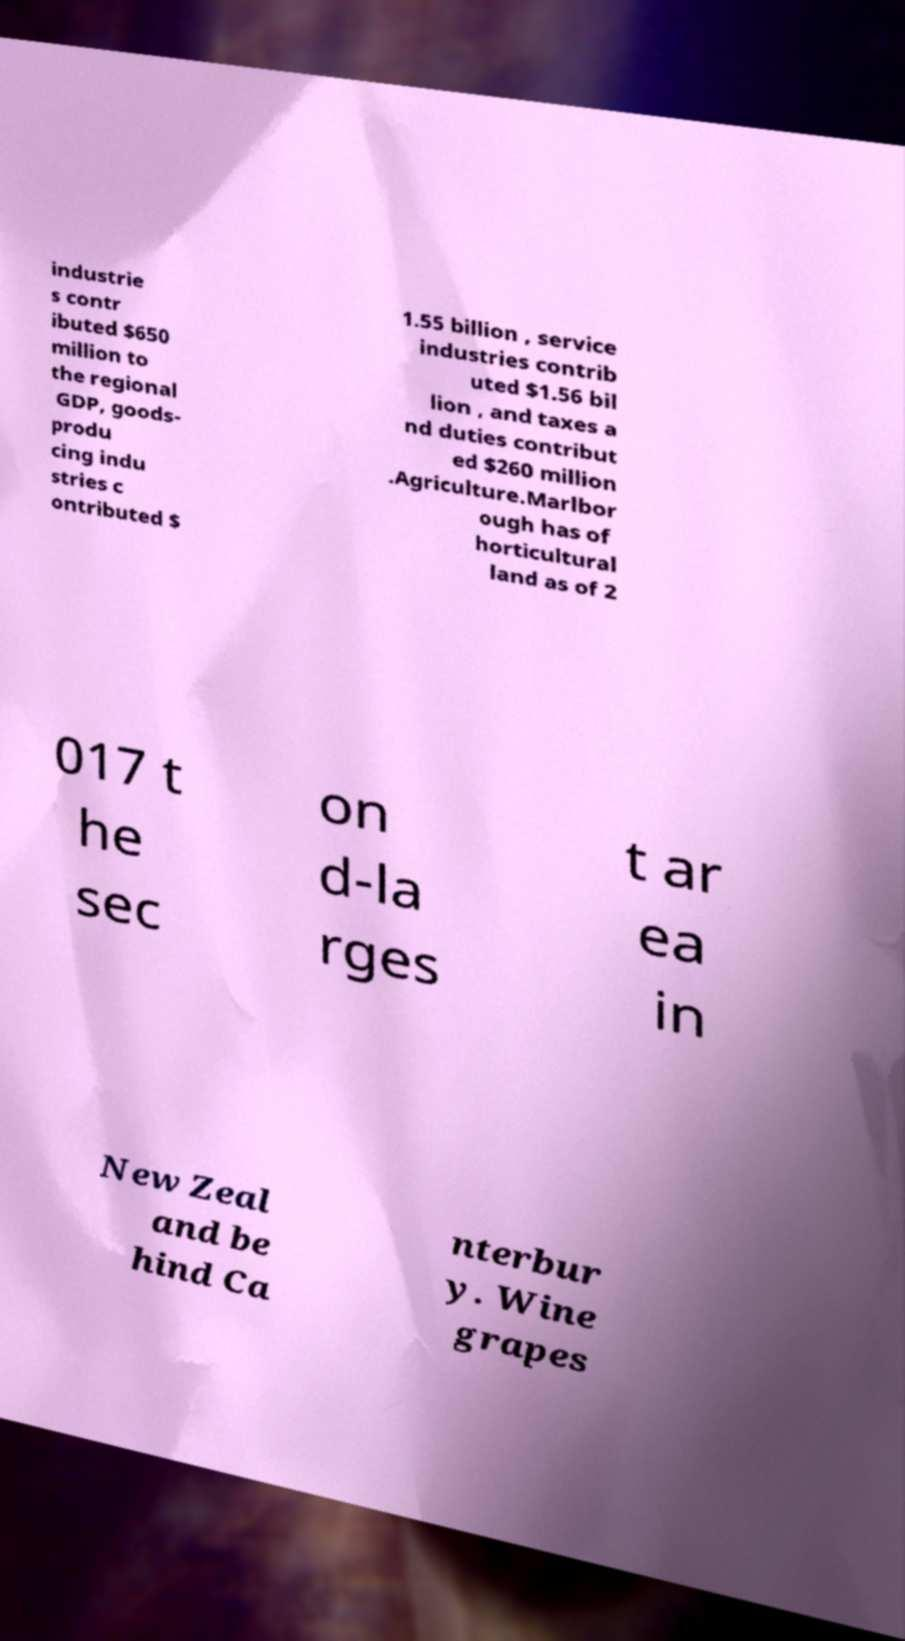Can you read and provide the text displayed in the image?This photo seems to have some interesting text. Can you extract and type it out for me? industrie s contr ibuted $650 million to the regional GDP, goods- produ cing indu stries c ontributed $ 1.55 billion , service industries contrib uted $1.56 bil lion , and taxes a nd duties contribut ed $260 million .Agriculture.Marlbor ough has of horticultural land as of 2 017 t he sec on d-la rges t ar ea in New Zeal and be hind Ca nterbur y. Wine grapes 